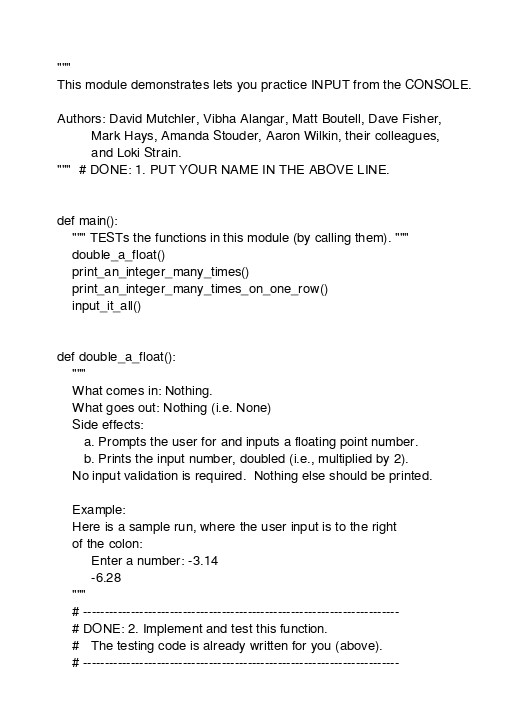Convert code to text. <code><loc_0><loc_0><loc_500><loc_500><_Python_>"""
This module demonstrates lets you practice INPUT from the CONSOLE.

Authors: David Mutchler, Vibha Alangar, Matt Boutell, Dave Fisher,
         Mark Hays, Amanda Stouder, Aaron Wilkin, their colleagues,
         and Loki Strain.
"""  # DONE: 1. PUT YOUR NAME IN THE ABOVE LINE.


def main():
    """ TESTs the functions in this module (by calling them). """
    double_a_float()
    print_an_integer_many_times()
    print_an_integer_many_times_on_one_row()
    input_it_all()


def double_a_float():
    """
    What comes in: Nothing.
    What goes out: Nothing (i.e. None)
    Side effects:
       a. Prompts the user for and inputs a floating point number.
       b. Prints the input number, doubled (i.e., multiplied by 2).
    No input validation is required.  Nothing else should be printed.

    Example:
    Here is a sample run, where the user input is to the right
    of the colon:
         Enter a number: -3.14
         -6.28
    """
    # -------------------------------------------------------------------------
    # DONE: 2. Implement and test this function.
    #   The testing code is already written for you (above).
    # -------------------------------------------------------------------------
</code> 